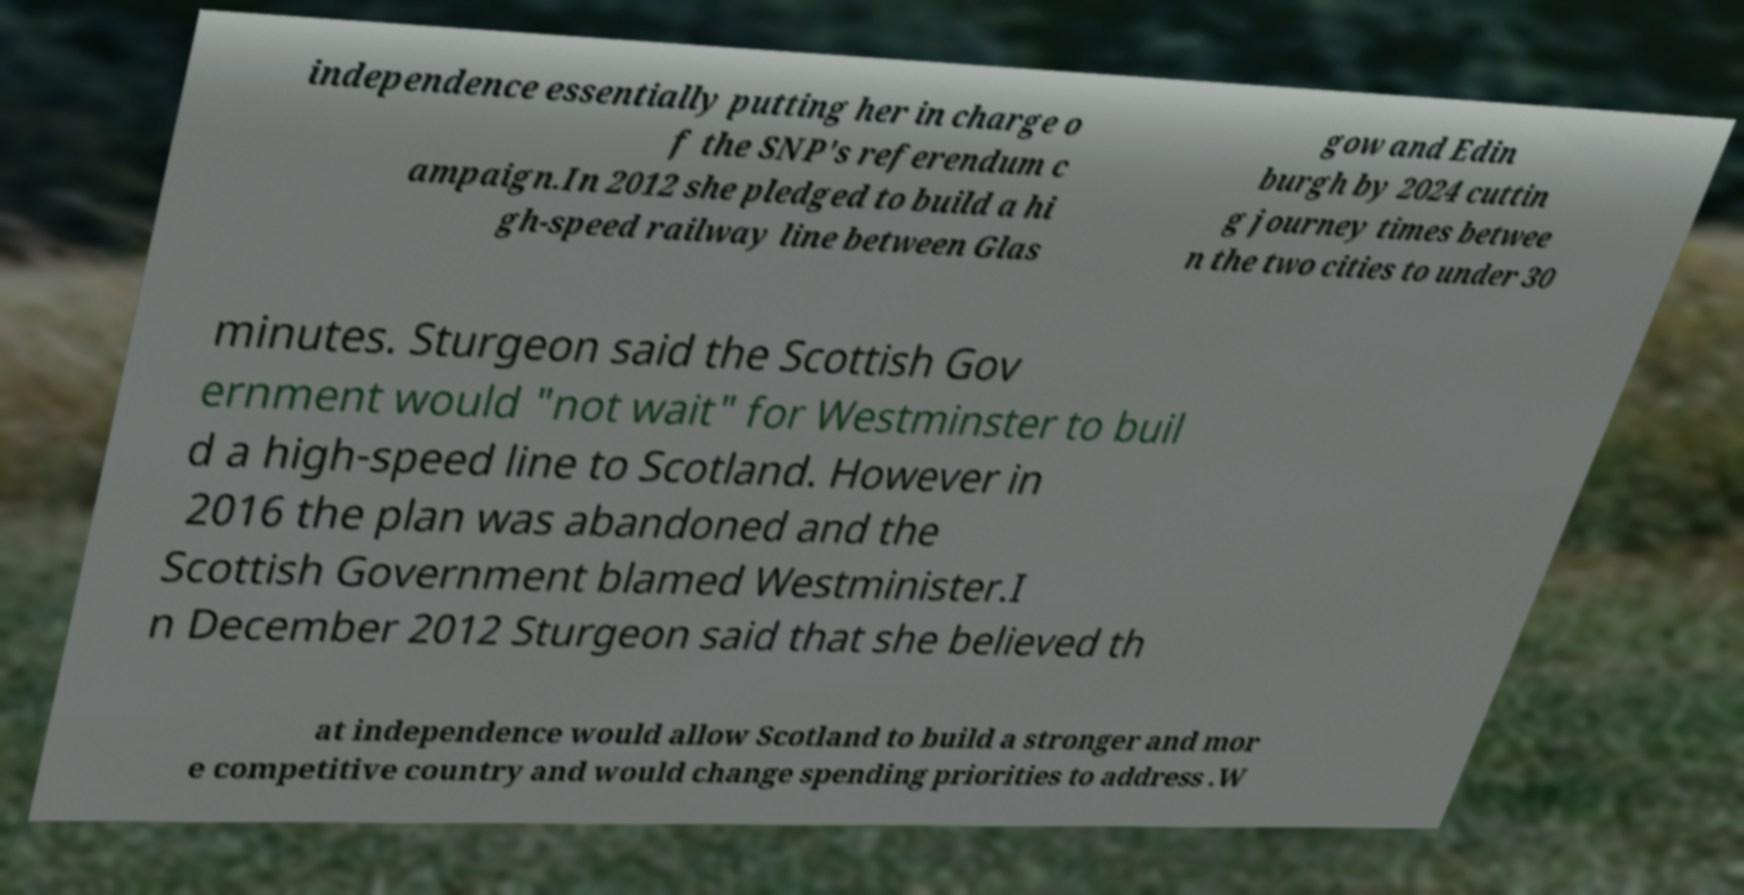Please read and relay the text visible in this image. What does it say? independence essentially putting her in charge o f the SNP's referendum c ampaign.In 2012 she pledged to build a hi gh-speed railway line between Glas gow and Edin burgh by 2024 cuttin g journey times betwee n the two cities to under 30 minutes. Sturgeon said the Scottish Gov ernment would "not wait" for Westminster to buil d a high-speed line to Scotland. However in 2016 the plan was abandoned and the Scottish Government blamed Westminister.I n December 2012 Sturgeon said that she believed th at independence would allow Scotland to build a stronger and mor e competitive country and would change spending priorities to address .W 